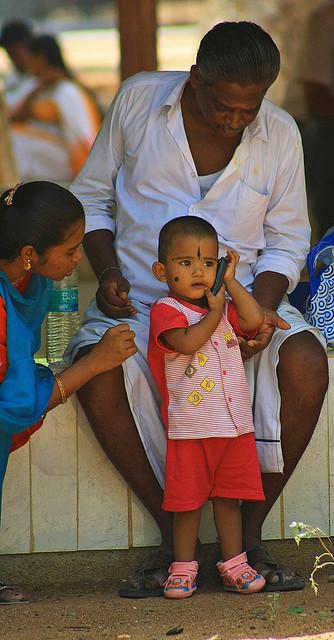What type of phone is being used? cellphone 